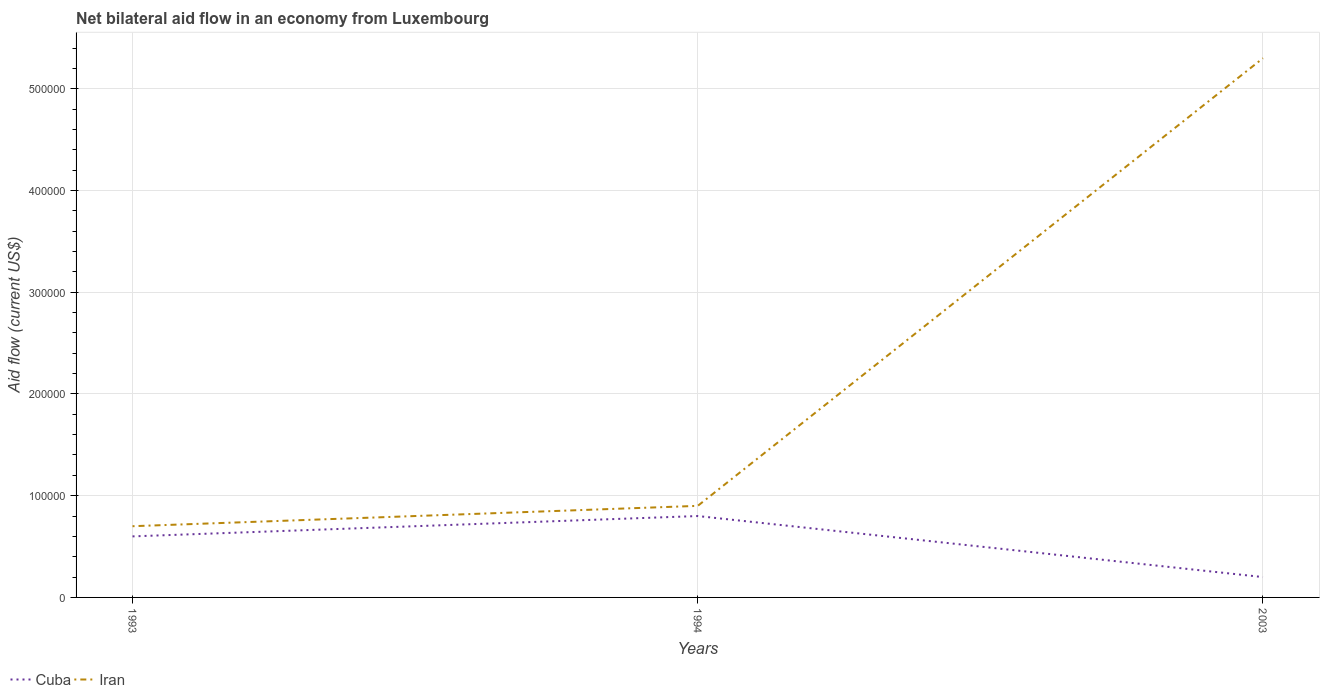What is the difference between the highest and the lowest net bilateral aid flow in Cuba?
Give a very brief answer. 2. Is the net bilateral aid flow in Cuba strictly greater than the net bilateral aid flow in Iran over the years?
Offer a terse response. Yes. How many lines are there?
Keep it short and to the point. 2. How many years are there in the graph?
Offer a very short reply. 3. Does the graph contain any zero values?
Ensure brevity in your answer.  No. Does the graph contain grids?
Your response must be concise. Yes. Where does the legend appear in the graph?
Give a very brief answer. Bottom left. What is the title of the graph?
Keep it short and to the point. Net bilateral aid flow in an economy from Luxembourg. What is the Aid flow (current US$) in Cuba in 1993?
Your answer should be compact. 6.00e+04. What is the Aid flow (current US$) in Cuba in 2003?
Keep it short and to the point. 2.00e+04. What is the Aid flow (current US$) of Iran in 2003?
Offer a terse response. 5.30e+05. Across all years, what is the maximum Aid flow (current US$) of Iran?
Your response must be concise. 5.30e+05. Across all years, what is the minimum Aid flow (current US$) in Cuba?
Ensure brevity in your answer.  2.00e+04. What is the total Aid flow (current US$) in Iran in the graph?
Provide a short and direct response. 6.90e+05. What is the difference between the Aid flow (current US$) of Cuba in 1993 and that in 2003?
Give a very brief answer. 4.00e+04. What is the difference between the Aid flow (current US$) in Iran in 1993 and that in 2003?
Ensure brevity in your answer.  -4.60e+05. What is the difference between the Aid flow (current US$) of Iran in 1994 and that in 2003?
Provide a short and direct response. -4.40e+05. What is the difference between the Aid flow (current US$) of Cuba in 1993 and the Aid flow (current US$) of Iran in 2003?
Make the answer very short. -4.70e+05. What is the difference between the Aid flow (current US$) of Cuba in 1994 and the Aid flow (current US$) of Iran in 2003?
Give a very brief answer. -4.50e+05. What is the average Aid flow (current US$) in Cuba per year?
Your answer should be very brief. 5.33e+04. What is the average Aid flow (current US$) in Iran per year?
Ensure brevity in your answer.  2.30e+05. In the year 1993, what is the difference between the Aid flow (current US$) in Cuba and Aid flow (current US$) in Iran?
Provide a short and direct response. -10000. In the year 1994, what is the difference between the Aid flow (current US$) of Cuba and Aid flow (current US$) of Iran?
Ensure brevity in your answer.  -10000. In the year 2003, what is the difference between the Aid flow (current US$) of Cuba and Aid flow (current US$) of Iran?
Offer a terse response. -5.10e+05. What is the ratio of the Aid flow (current US$) of Iran in 1993 to that in 2003?
Your answer should be very brief. 0.13. What is the ratio of the Aid flow (current US$) in Iran in 1994 to that in 2003?
Make the answer very short. 0.17. What is the difference between the highest and the second highest Aid flow (current US$) of Cuba?
Provide a short and direct response. 2.00e+04. What is the difference between the highest and the second highest Aid flow (current US$) of Iran?
Provide a succinct answer. 4.40e+05. What is the difference between the highest and the lowest Aid flow (current US$) in Iran?
Your answer should be very brief. 4.60e+05. 